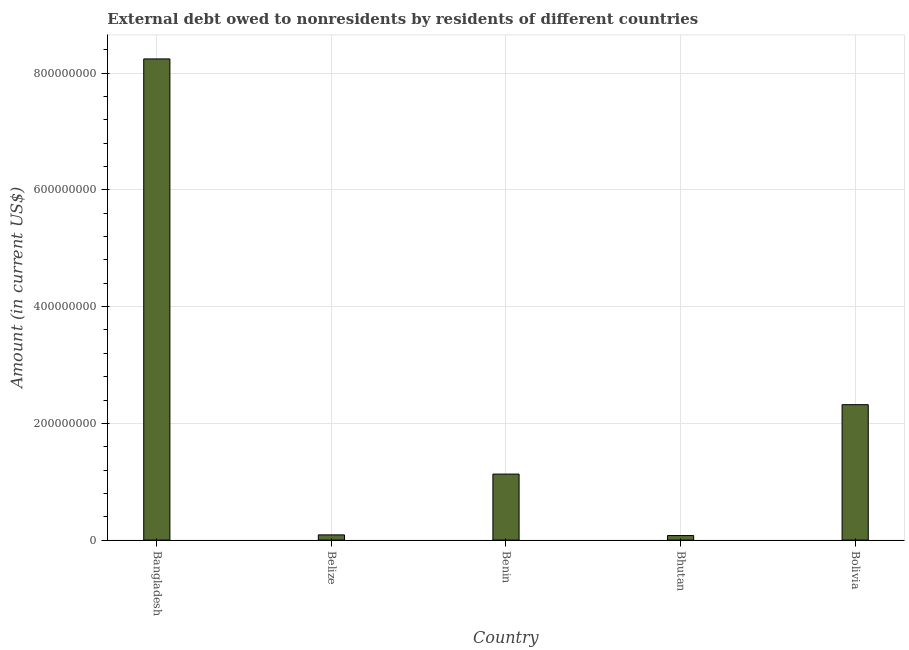What is the title of the graph?
Keep it short and to the point. External debt owed to nonresidents by residents of different countries. What is the label or title of the Y-axis?
Offer a terse response. Amount (in current US$). What is the debt in Bhutan?
Your answer should be compact. 7.79e+06. Across all countries, what is the maximum debt?
Your answer should be compact. 8.24e+08. Across all countries, what is the minimum debt?
Your answer should be compact. 7.79e+06. In which country was the debt maximum?
Your response must be concise. Bangladesh. In which country was the debt minimum?
Your response must be concise. Bhutan. What is the sum of the debt?
Your response must be concise. 1.19e+09. What is the difference between the debt in Benin and Bhutan?
Offer a terse response. 1.05e+08. What is the average debt per country?
Your response must be concise. 2.37e+08. What is the median debt?
Your answer should be compact. 1.13e+08. What is the ratio of the debt in Belize to that in Bolivia?
Provide a short and direct response. 0.04. Is the debt in Benin less than that in Bhutan?
Offer a terse response. No. What is the difference between the highest and the second highest debt?
Your answer should be compact. 5.92e+08. Is the sum of the debt in Benin and Bhutan greater than the maximum debt across all countries?
Make the answer very short. No. What is the difference between the highest and the lowest debt?
Offer a terse response. 8.17e+08. Are the values on the major ticks of Y-axis written in scientific E-notation?
Make the answer very short. No. What is the Amount (in current US$) of Bangladesh?
Keep it short and to the point. 8.24e+08. What is the Amount (in current US$) of Belize?
Keep it short and to the point. 8.94e+06. What is the Amount (in current US$) in Benin?
Provide a short and direct response. 1.13e+08. What is the Amount (in current US$) in Bhutan?
Provide a short and direct response. 7.79e+06. What is the Amount (in current US$) in Bolivia?
Ensure brevity in your answer.  2.32e+08. What is the difference between the Amount (in current US$) in Bangladesh and Belize?
Your answer should be very brief. 8.15e+08. What is the difference between the Amount (in current US$) in Bangladesh and Benin?
Offer a very short reply. 7.11e+08. What is the difference between the Amount (in current US$) in Bangladesh and Bhutan?
Your response must be concise. 8.17e+08. What is the difference between the Amount (in current US$) in Bangladesh and Bolivia?
Your answer should be very brief. 5.92e+08. What is the difference between the Amount (in current US$) in Belize and Benin?
Offer a terse response. -1.04e+08. What is the difference between the Amount (in current US$) in Belize and Bhutan?
Offer a very short reply. 1.15e+06. What is the difference between the Amount (in current US$) in Belize and Bolivia?
Give a very brief answer. -2.23e+08. What is the difference between the Amount (in current US$) in Benin and Bhutan?
Your response must be concise. 1.05e+08. What is the difference between the Amount (in current US$) in Benin and Bolivia?
Offer a very short reply. -1.19e+08. What is the difference between the Amount (in current US$) in Bhutan and Bolivia?
Your response must be concise. -2.24e+08. What is the ratio of the Amount (in current US$) in Bangladesh to that in Belize?
Provide a succinct answer. 92.19. What is the ratio of the Amount (in current US$) in Bangladesh to that in Benin?
Provide a succinct answer. 7.29. What is the ratio of the Amount (in current US$) in Bangladesh to that in Bhutan?
Provide a succinct answer. 105.78. What is the ratio of the Amount (in current US$) in Bangladesh to that in Bolivia?
Offer a terse response. 3.55. What is the ratio of the Amount (in current US$) in Belize to that in Benin?
Offer a very short reply. 0.08. What is the ratio of the Amount (in current US$) in Belize to that in Bhutan?
Your answer should be compact. 1.15. What is the ratio of the Amount (in current US$) in Belize to that in Bolivia?
Offer a very short reply. 0.04. What is the ratio of the Amount (in current US$) in Benin to that in Bhutan?
Provide a succinct answer. 14.51. What is the ratio of the Amount (in current US$) in Benin to that in Bolivia?
Your answer should be very brief. 0.49. What is the ratio of the Amount (in current US$) in Bhutan to that in Bolivia?
Make the answer very short. 0.03. 